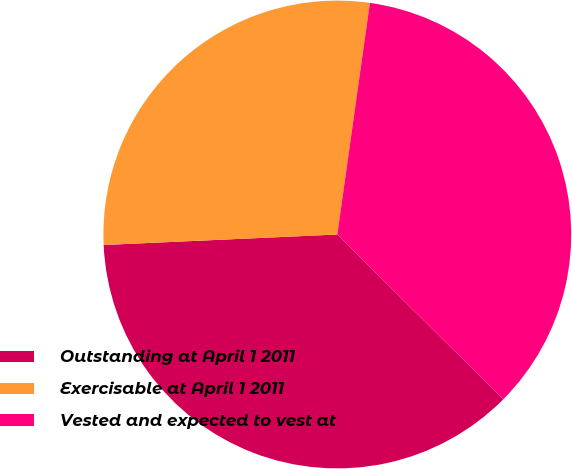Convert chart to OTSL. <chart><loc_0><loc_0><loc_500><loc_500><pie_chart><fcel>Outstanding at April 1 2011<fcel>Exercisable at April 1 2011<fcel>Vested and expected to vest at<nl><fcel>36.84%<fcel>27.94%<fcel>35.22%<nl></chart> 